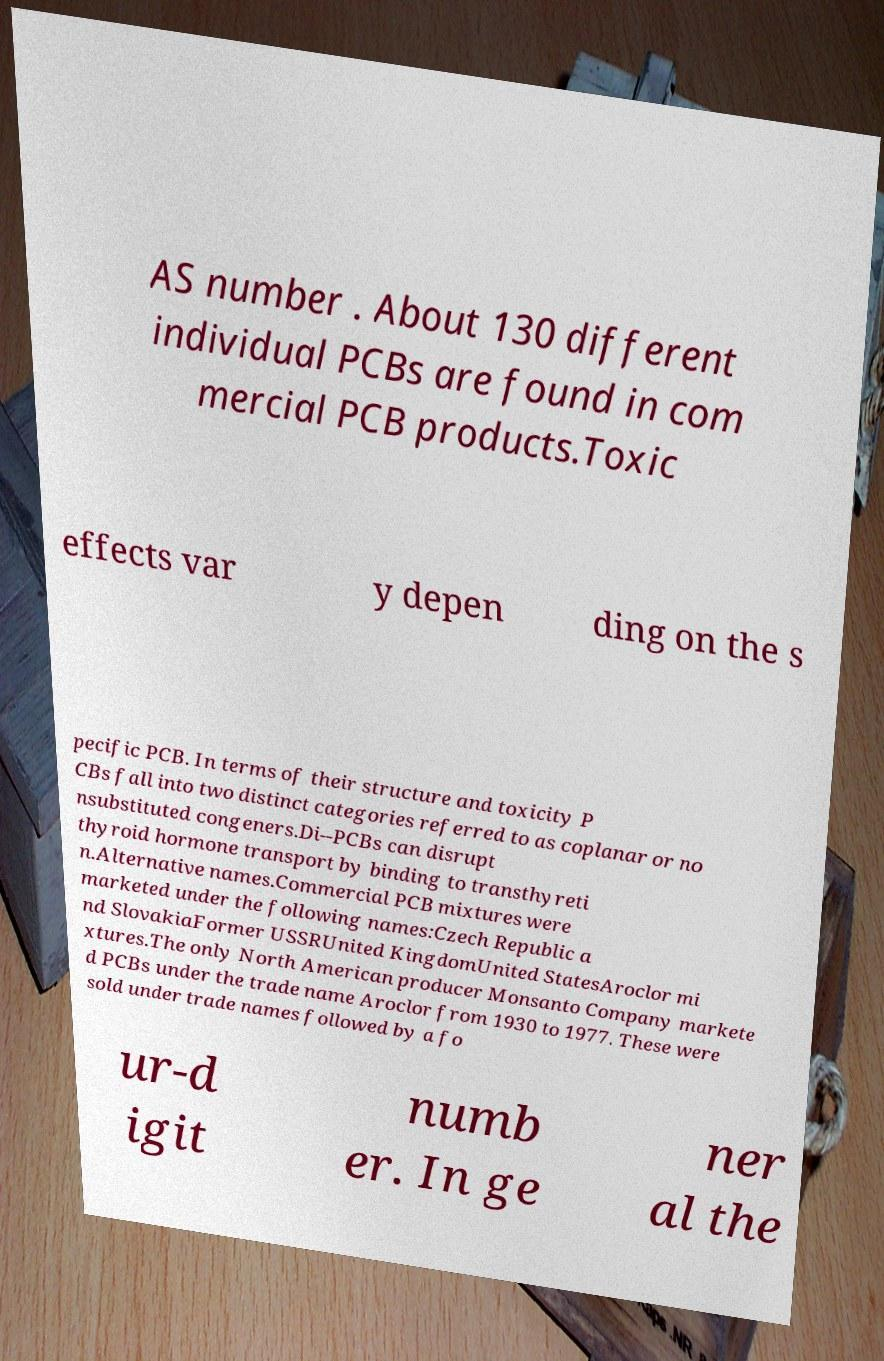Please identify and transcribe the text found in this image. AS number . About 130 different individual PCBs are found in com mercial PCB products.Toxic effects var y depen ding on the s pecific PCB. In terms of their structure and toxicity P CBs fall into two distinct categories referred to as coplanar or no nsubstituted congeners.Di--PCBs can disrupt thyroid hormone transport by binding to transthyreti n.Alternative names.Commercial PCB mixtures were marketed under the following names:Czech Republic a nd SlovakiaFormer USSRUnited KingdomUnited StatesAroclor mi xtures.The only North American producer Monsanto Company markete d PCBs under the trade name Aroclor from 1930 to 1977. These were sold under trade names followed by a fo ur-d igit numb er. In ge ner al the 